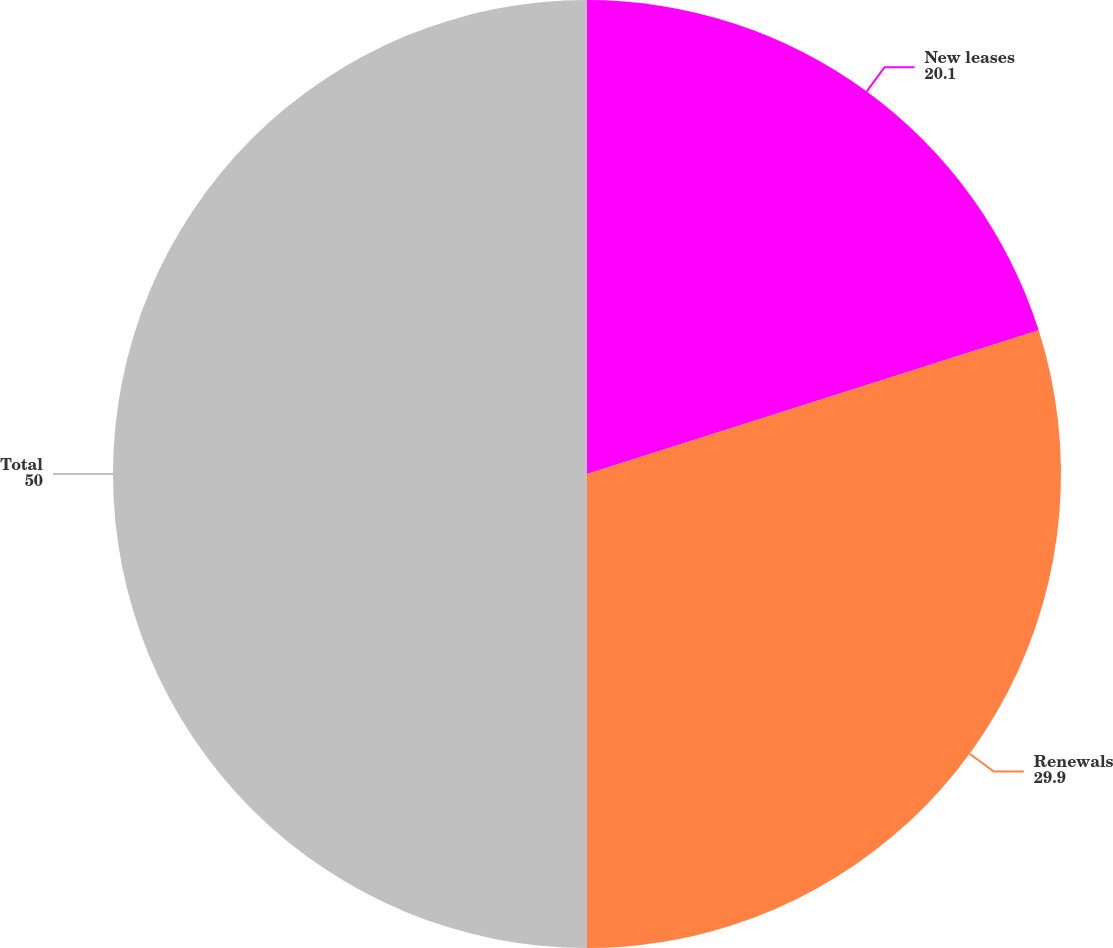Convert chart. <chart><loc_0><loc_0><loc_500><loc_500><pie_chart><fcel>New leases<fcel>Renewals<fcel>Total<nl><fcel>20.1%<fcel>29.9%<fcel>50.0%<nl></chart> 